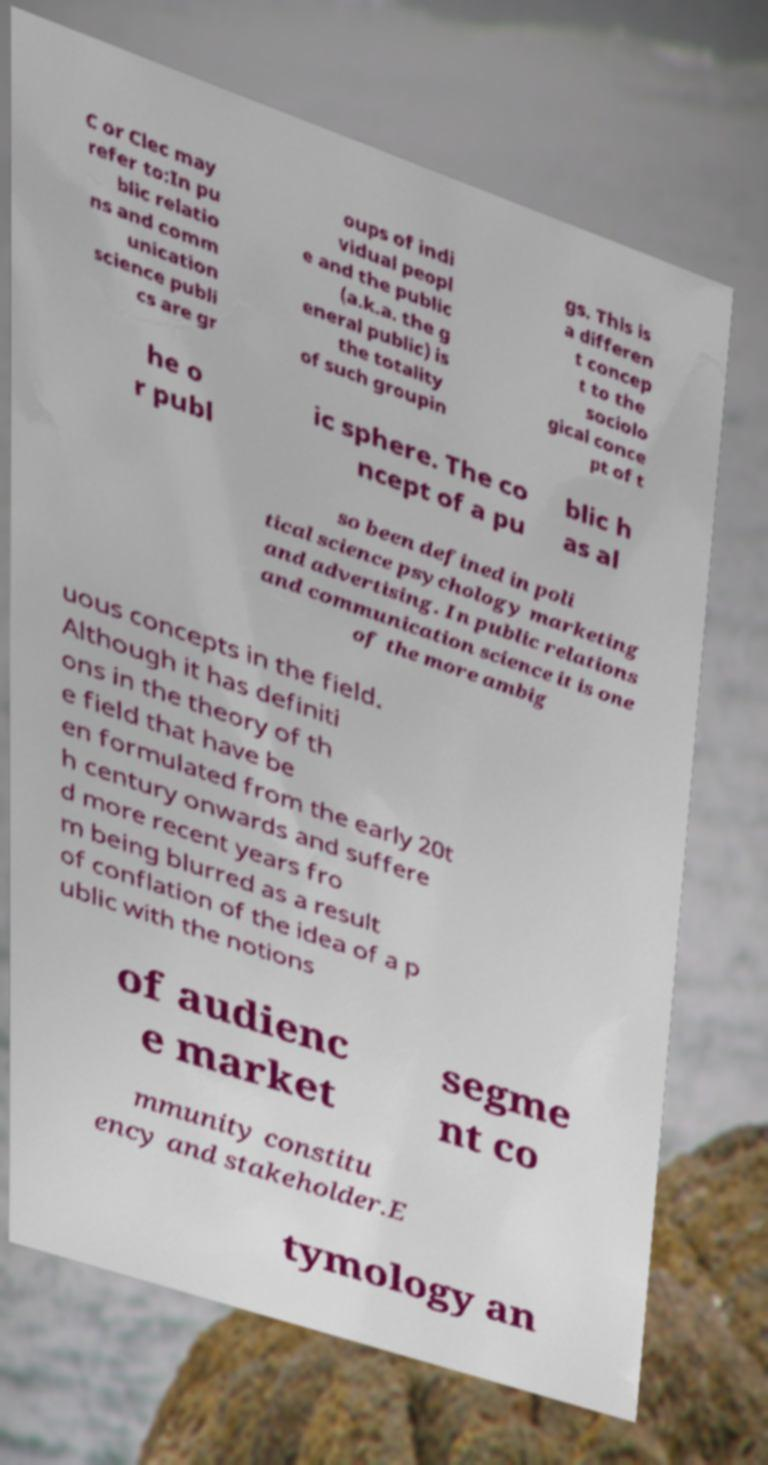Please read and relay the text visible in this image. What does it say? C or Clec may refer to:In pu blic relatio ns and comm unication science publi cs are gr oups of indi vidual peopl e and the public (a.k.a. the g eneral public) is the totality of such groupin gs. This is a differen t concep t to the sociolo gical conce pt of t he o r publ ic sphere. The co ncept of a pu blic h as al so been defined in poli tical science psychology marketing and advertising. In public relations and communication science it is one of the more ambig uous concepts in the field. Although it has definiti ons in the theory of th e field that have be en formulated from the early 20t h century onwards and suffere d more recent years fro m being blurred as a result of conflation of the idea of a p ublic with the notions of audienc e market segme nt co mmunity constitu ency and stakeholder.E tymology an 